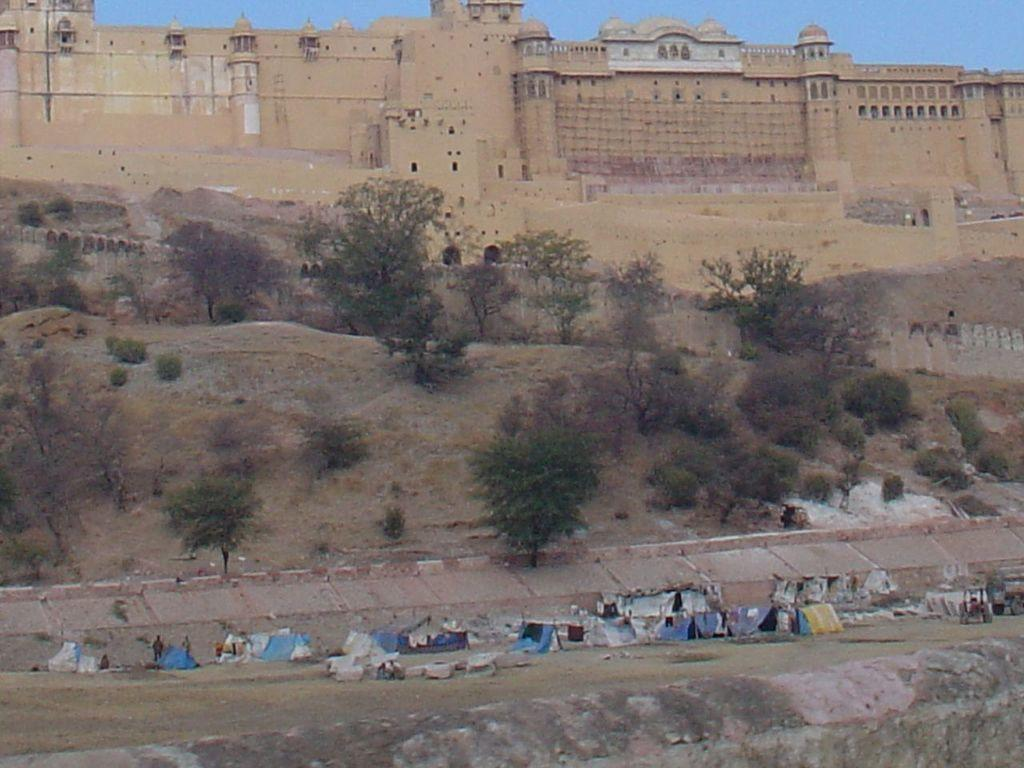What is present in the image that is being hit? There are hits in the image, but the specific object being hit is not mentioned. What can be seen in the background of the image? There are trees and buildings in the background of the image. What is the color of the trees in the image? The trees in the image are green. What is the color of the buildings in the image? The buildings in the image are brown. What is visible above the trees and buildings in the image? The sky is visible in the background of the image. What is the color of the sky in the image? The sky in the image is blue. How many achievers can be seen in the image? There are no achievers mentioned or visible in the image. 